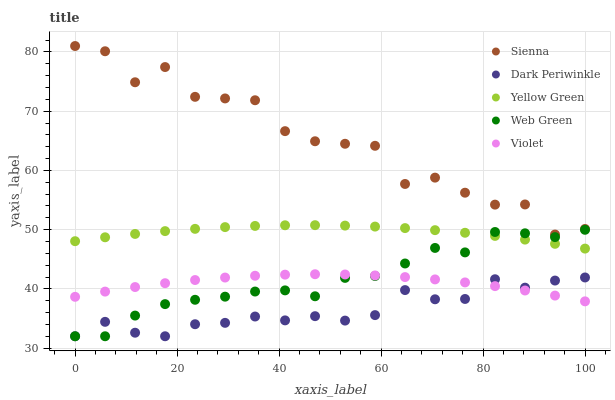Does Dark Periwinkle have the minimum area under the curve?
Answer yes or no. Yes. Does Sienna have the maximum area under the curve?
Answer yes or no. Yes. Does Violet have the minimum area under the curve?
Answer yes or no. No. Does Violet have the maximum area under the curve?
Answer yes or no. No. Is Yellow Green the smoothest?
Answer yes or no. Yes. Is Sienna the roughest?
Answer yes or no. Yes. Is Violet the smoothest?
Answer yes or no. No. Is Violet the roughest?
Answer yes or no. No. Does Dark Periwinkle have the lowest value?
Answer yes or no. Yes. Does Violet have the lowest value?
Answer yes or no. No. Does Sienna have the highest value?
Answer yes or no. Yes. Does Violet have the highest value?
Answer yes or no. No. Is Dark Periwinkle less than Sienna?
Answer yes or no. Yes. Is Sienna greater than Web Green?
Answer yes or no. Yes. Does Web Green intersect Yellow Green?
Answer yes or no. Yes. Is Web Green less than Yellow Green?
Answer yes or no. No. Is Web Green greater than Yellow Green?
Answer yes or no. No. Does Dark Periwinkle intersect Sienna?
Answer yes or no. No. 